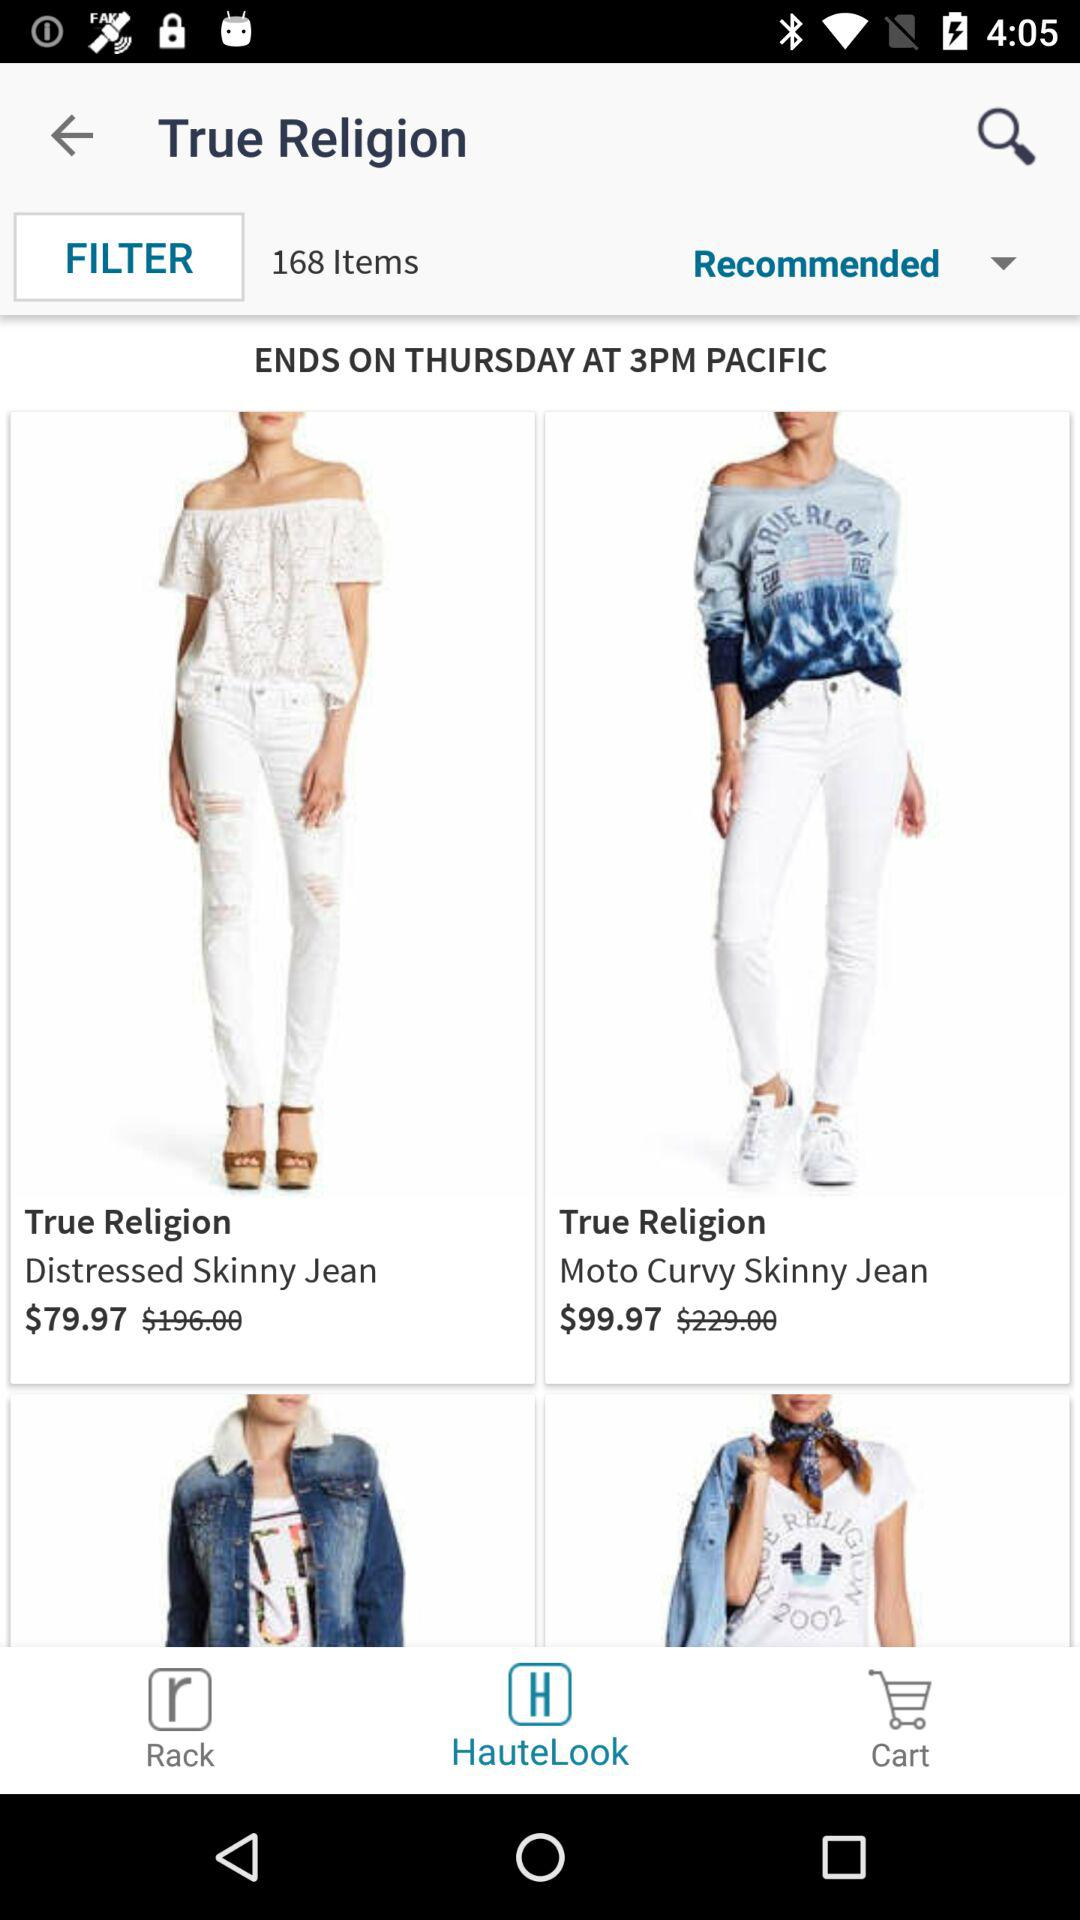What is the company name of the jeans? The company name is "True Religion". 